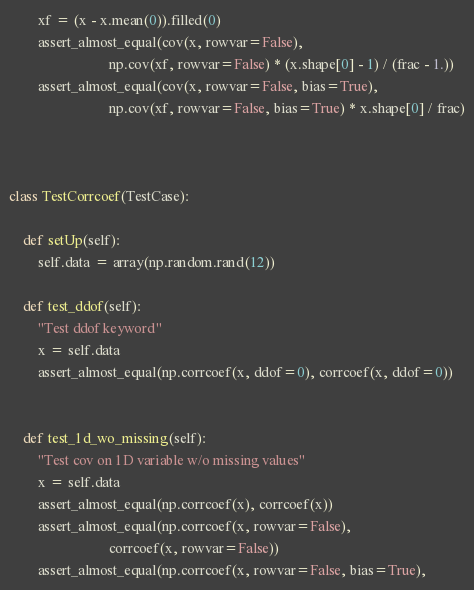Convert code to text. <code><loc_0><loc_0><loc_500><loc_500><_Python_>        xf = (x - x.mean(0)).filled(0)
        assert_almost_equal(cov(x, rowvar=False),
                            np.cov(xf, rowvar=False) * (x.shape[0] - 1) / (frac - 1.))
        assert_almost_equal(cov(x, rowvar=False, bias=True),
                            np.cov(xf, rowvar=False, bias=True) * x.shape[0] / frac)



class TestCorrcoef(TestCase):

    def setUp(self):
        self.data = array(np.random.rand(12))

    def test_ddof(self):
        "Test ddof keyword"
        x = self.data
        assert_almost_equal(np.corrcoef(x, ddof=0), corrcoef(x, ddof=0))


    def test_1d_wo_missing(self):
        "Test cov on 1D variable w/o missing values"
        x = self.data
        assert_almost_equal(np.corrcoef(x), corrcoef(x))
        assert_almost_equal(np.corrcoef(x, rowvar=False),
                            corrcoef(x, rowvar=False))
        assert_almost_equal(np.corrcoef(x, rowvar=False, bias=True),</code> 